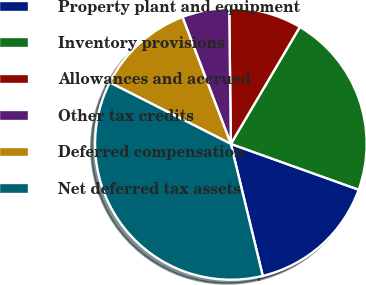Convert chart. <chart><loc_0><loc_0><loc_500><loc_500><pie_chart><fcel>Property plant and equipment<fcel>Inventory provisions<fcel>Allowances and accrued<fcel>Other tax credits<fcel>Deferred compensation<fcel>Net deferred tax assets<nl><fcel>15.75%<fcel>21.99%<fcel>8.67%<fcel>5.61%<fcel>11.73%<fcel>36.24%<nl></chart> 